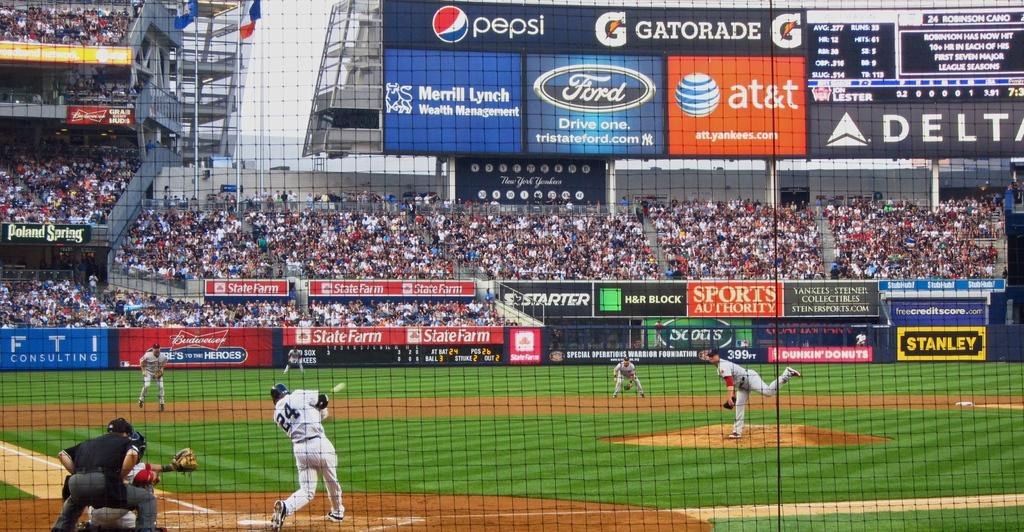<image>
Offer a succinct explanation of the picture presented. A baseball player swinging at a pitch with the number 24 on it. 